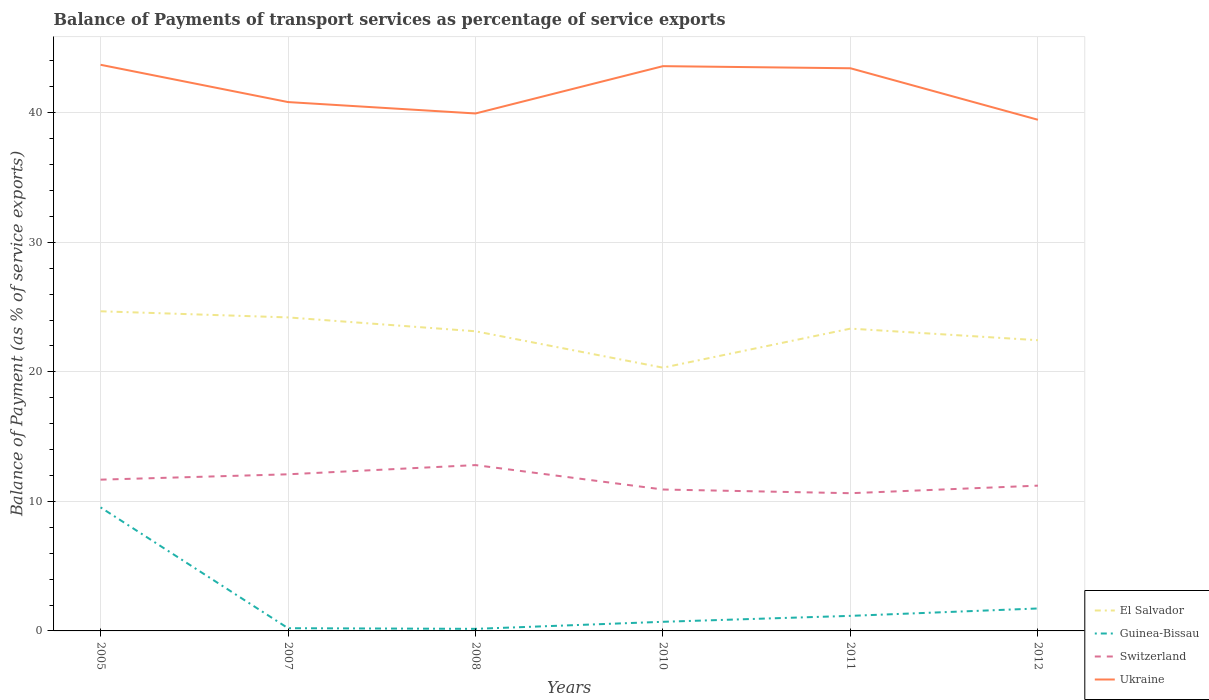How many different coloured lines are there?
Make the answer very short. 4. Across all years, what is the maximum balance of payments of transport services in Guinea-Bissau?
Offer a terse response. 0.16. What is the total balance of payments of transport services in Ukraine in the graph?
Make the answer very short. 0.11. What is the difference between the highest and the second highest balance of payments of transport services in El Salvador?
Provide a short and direct response. 4.36. How many lines are there?
Keep it short and to the point. 4. What is the difference between two consecutive major ticks on the Y-axis?
Ensure brevity in your answer.  10. Are the values on the major ticks of Y-axis written in scientific E-notation?
Your answer should be compact. No. Where does the legend appear in the graph?
Your answer should be very brief. Bottom right. How many legend labels are there?
Offer a terse response. 4. What is the title of the graph?
Offer a very short reply. Balance of Payments of transport services as percentage of service exports. What is the label or title of the Y-axis?
Your answer should be compact. Balance of Payment (as % of service exports). What is the Balance of Payment (as % of service exports) of El Salvador in 2005?
Your answer should be compact. 24.68. What is the Balance of Payment (as % of service exports) of Guinea-Bissau in 2005?
Your answer should be very brief. 9.54. What is the Balance of Payment (as % of service exports) of Switzerland in 2005?
Give a very brief answer. 11.68. What is the Balance of Payment (as % of service exports) of Ukraine in 2005?
Your answer should be compact. 43.71. What is the Balance of Payment (as % of service exports) in El Salvador in 2007?
Keep it short and to the point. 24.2. What is the Balance of Payment (as % of service exports) in Guinea-Bissau in 2007?
Provide a succinct answer. 0.21. What is the Balance of Payment (as % of service exports) of Switzerland in 2007?
Provide a succinct answer. 12.09. What is the Balance of Payment (as % of service exports) in Ukraine in 2007?
Provide a short and direct response. 40.83. What is the Balance of Payment (as % of service exports) of El Salvador in 2008?
Offer a terse response. 23.13. What is the Balance of Payment (as % of service exports) of Guinea-Bissau in 2008?
Give a very brief answer. 0.16. What is the Balance of Payment (as % of service exports) of Switzerland in 2008?
Provide a succinct answer. 12.8. What is the Balance of Payment (as % of service exports) of Ukraine in 2008?
Offer a very short reply. 39.95. What is the Balance of Payment (as % of service exports) of El Salvador in 2010?
Your response must be concise. 20.32. What is the Balance of Payment (as % of service exports) in Guinea-Bissau in 2010?
Provide a succinct answer. 0.7. What is the Balance of Payment (as % of service exports) in Switzerland in 2010?
Offer a terse response. 10.92. What is the Balance of Payment (as % of service exports) in Ukraine in 2010?
Provide a succinct answer. 43.6. What is the Balance of Payment (as % of service exports) of El Salvador in 2011?
Offer a very short reply. 23.34. What is the Balance of Payment (as % of service exports) in Guinea-Bissau in 2011?
Your answer should be compact. 1.16. What is the Balance of Payment (as % of service exports) in Switzerland in 2011?
Offer a terse response. 10.63. What is the Balance of Payment (as % of service exports) in Ukraine in 2011?
Offer a very short reply. 43.44. What is the Balance of Payment (as % of service exports) in El Salvador in 2012?
Your answer should be compact. 22.44. What is the Balance of Payment (as % of service exports) in Guinea-Bissau in 2012?
Ensure brevity in your answer.  1.73. What is the Balance of Payment (as % of service exports) in Switzerland in 2012?
Make the answer very short. 11.22. What is the Balance of Payment (as % of service exports) of Ukraine in 2012?
Give a very brief answer. 39.46. Across all years, what is the maximum Balance of Payment (as % of service exports) in El Salvador?
Provide a short and direct response. 24.68. Across all years, what is the maximum Balance of Payment (as % of service exports) in Guinea-Bissau?
Give a very brief answer. 9.54. Across all years, what is the maximum Balance of Payment (as % of service exports) in Switzerland?
Ensure brevity in your answer.  12.8. Across all years, what is the maximum Balance of Payment (as % of service exports) in Ukraine?
Give a very brief answer. 43.71. Across all years, what is the minimum Balance of Payment (as % of service exports) of El Salvador?
Keep it short and to the point. 20.32. Across all years, what is the minimum Balance of Payment (as % of service exports) of Guinea-Bissau?
Give a very brief answer. 0.16. Across all years, what is the minimum Balance of Payment (as % of service exports) of Switzerland?
Provide a succinct answer. 10.63. Across all years, what is the minimum Balance of Payment (as % of service exports) of Ukraine?
Offer a very short reply. 39.46. What is the total Balance of Payment (as % of service exports) of El Salvador in the graph?
Provide a short and direct response. 138.12. What is the total Balance of Payment (as % of service exports) of Guinea-Bissau in the graph?
Give a very brief answer. 13.51. What is the total Balance of Payment (as % of service exports) of Switzerland in the graph?
Ensure brevity in your answer.  69.34. What is the total Balance of Payment (as % of service exports) of Ukraine in the graph?
Offer a very short reply. 250.99. What is the difference between the Balance of Payment (as % of service exports) in El Salvador in 2005 and that in 2007?
Offer a terse response. 0.47. What is the difference between the Balance of Payment (as % of service exports) in Guinea-Bissau in 2005 and that in 2007?
Offer a very short reply. 9.33. What is the difference between the Balance of Payment (as % of service exports) of Switzerland in 2005 and that in 2007?
Provide a succinct answer. -0.41. What is the difference between the Balance of Payment (as % of service exports) in Ukraine in 2005 and that in 2007?
Keep it short and to the point. 2.88. What is the difference between the Balance of Payment (as % of service exports) of El Salvador in 2005 and that in 2008?
Your response must be concise. 1.54. What is the difference between the Balance of Payment (as % of service exports) of Guinea-Bissau in 2005 and that in 2008?
Make the answer very short. 9.38. What is the difference between the Balance of Payment (as % of service exports) of Switzerland in 2005 and that in 2008?
Offer a terse response. -1.12. What is the difference between the Balance of Payment (as % of service exports) in Ukraine in 2005 and that in 2008?
Your answer should be very brief. 3.76. What is the difference between the Balance of Payment (as % of service exports) of El Salvador in 2005 and that in 2010?
Your answer should be very brief. 4.36. What is the difference between the Balance of Payment (as % of service exports) in Guinea-Bissau in 2005 and that in 2010?
Make the answer very short. 8.83. What is the difference between the Balance of Payment (as % of service exports) in Switzerland in 2005 and that in 2010?
Provide a succinct answer. 0.76. What is the difference between the Balance of Payment (as % of service exports) in Ukraine in 2005 and that in 2010?
Offer a terse response. 0.11. What is the difference between the Balance of Payment (as % of service exports) of El Salvador in 2005 and that in 2011?
Offer a very short reply. 1.34. What is the difference between the Balance of Payment (as % of service exports) of Guinea-Bissau in 2005 and that in 2011?
Provide a short and direct response. 8.37. What is the difference between the Balance of Payment (as % of service exports) in Switzerland in 2005 and that in 2011?
Provide a short and direct response. 1.05. What is the difference between the Balance of Payment (as % of service exports) of Ukraine in 2005 and that in 2011?
Your answer should be compact. 0.27. What is the difference between the Balance of Payment (as % of service exports) of El Salvador in 2005 and that in 2012?
Your response must be concise. 2.23. What is the difference between the Balance of Payment (as % of service exports) of Guinea-Bissau in 2005 and that in 2012?
Make the answer very short. 7.8. What is the difference between the Balance of Payment (as % of service exports) in Switzerland in 2005 and that in 2012?
Make the answer very short. 0.46. What is the difference between the Balance of Payment (as % of service exports) in Ukraine in 2005 and that in 2012?
Keep it short and to the point. 4.25. What is the difference between the Balance of Payment (as % of service exports) in El Salvador in 2007 and that in 2008?
Keep it short and to the point. 1.07. What is the difference between the Balance of Payment (as % of service exports) of Guinea-Bissau in 2007 and that in 2008?
Provide a short and direct response. 0.05. What is the difference between the Balance of Payment (as % of service exports) of Switzerland in 2007 and that in 2008?
Your response must be concise. -0.71. What is the difference between the Balance of Payment (as % of service exports) in Ukraine in 2007 and that in 2008?
Make the answer very short. 0.88. What is the difference between the Balance of Payment (as % of service exports) of El Salvador in 2007 and that in 2010?
Offer a very short reply. 3.88. What is the difference between the Balance of Payment (as % of service exports) in Guinea-Bissau in 2007 and that in 2010?
Keep it short and to the point. -0.5. What is the difference between the Balance of Payment (as % of service exports) of Switzerland in 2007 and that in 2010?
Make the answer very short. 1.17. What is the difference between the Balance of Payment (as % of service exports) in Ukraine in 2007 and that in 2010?
Give a very brief answer. -2.77. What is the difference between the Balance of Payment (as % of service exports) in El Salvador in 2007 and that in 2011?
Give a very brief answer. 0.87. What is the difference between the Balance of Payment (as % of service exports) of Guinea-Bissau in 2007 and that in 2011?
Your answer should be compact. -0.95. What is the difference between the Balance of Payment (as % of service exports) of Switzerland in 2007 and that in 2011?
Your response must be concise. 1.46. What is the difference between the Balance of Payment (as % of service exports) of Ukraine in 2007 and that in 2011?
Your response must be concise. -2.61. What is the difference between the Balance of Payment (as % of service exports) of El Salvador in 2007 and that in 2012?
Give a very brief answer. 1.76. What is the difference between the Balance of Payment (as % of service exports) of Guinea-Bissau in 2007 and that in 2012?
Provide a succinct answer. -1.52. What is the difference between the Balance of Payment (as % of service exports) of Switzerland in 2007 and that in 2012?
Your answer should be compact. 0.88. What is the difference between the Balance of Payment (as % of service exports) of Ukraine in 2007 and that in 2012?
Give a very brief answer. 1.37. What is the difference between the Balance of Payment (as % of service exports) of El Salvador in 2008 and that in 2010?
Make the answer very short. 2.81. What is the difference between the Balance of Payment (as % of service exports) in Guinea-Bissau in 2008 and that in 2010?
Provide a succinct answer. -0.54. What is the difference between the Balance of Payment (as % of service exports) of Switzerland in 2008 and that in 2010?
Your answer should be very brief. 1.89. What is the difference between the Balance of Payment (as % of service exports) in Ukraine in 2008 and that in 2010?
Keep it short and to the point. -3.65. What is the difference between the Balance of Payment (as % of service exports) of El Salvador in 2008 and that in 2011?
Make the answer very short. -0.2. What is the difference between the Balance of Payment (as % of service exports) in Guinea-Bissau in 2008 and that in 2011?
Provide a short and direct response. -1. What is the difference between the Balance of Payment (as % of service exports) in Switzerland in 2008 and that in 2011?
Offer a very short reply. 2.17. What is the difference between the Balance of Payment (as % of service exports) of Ukraine in 2008 and that in 2011?
Provide a short and direct response. -3.49. What is the difference between the Balance of Payment (as % of service exports) in El Salvador in 2008 and that in 2012?
Give a very brief answer. 0.69. What is the difference between the Balance of Payment (as % of service exports) of Guinea-Bissau in 2008 and that in 2012?
Make the answer very short. -1.57. What is the difference between the Balance of Payment (as % of service exports) of Switzerland in 2008 and that in 2012?
Provide a succinct answer. 1.59. What is the difference between the Balance of Payment (as % of service exports) in Ukraine in 2008 and that in 2012?
Provide a short and direct response. 0.49. What is the difference between the Balance of Payment (as % of service exports) of El Salvador in 2010 and that in 2011?
Your answer should be compact. -3.02. What is the difference between the Balance of Payment (as % of service exports) in Guinea-Bissau in 2010 and that in 2011?
Your response must be concise. -0.46. What is the difference between the Balance of Payment (as % of service exports) in Switzerland in 2010 and that in 2011?
Make the answer very short. 0.28. What is the difference between the Balance of Payment (as % of service exports) in Ukraine in 2010 and that in 2011?
Offer a very short reply. 0.16. What is the difference between the Balance of Payment (as % of service exports) in El Salvador in 2010 and that in 2012?
Offer a terse response. -2.12. What is the difference between the Balance of Payment (as % of service exports) of Guinea-Bissau in 2010 and that in 2012?
Provide a short and direct response. -1.03. What is the difference between the Balance of Payment (as % of service exports) of Switzerland in 2010 and that in 2012?
Provide a short and direct response. -0.3. What is the difference between the Balance of Payment (as % of service exports) in Ukraine in 2010 and that in 2012?
Your response must be concise. 4.14. What is the difference between the Balance of Payment (as % of service exports) of El Salvador in 2011 and that in 2012?
Your answer should be compact. 0.89. What is the difference between the Balance of Payment (as % of service exports) of Guinea-Bissau in 2011 and that in 2012?
Your answer should be very brief. -0.57. What is the difference between the Balance of Payment (as % of service exports) in Switzerland in 2011 and that in 2012?
Make the answer very short. -0.58. What is the difference between the Balance of Payment (as % of service exports) of Ukraine in 2011 and that in 2012?
Your answer should be very brief. 3.98. What is the difference between the Balance of Payment (as % of service exports) of El Salvador in 2005 and the Balance of Payment (as % of service exports) of Guinea-Bissau in 2007?
Your response must be concise. 24.47. What is the difference between the Balance of Payment (as % of service exports) in El Salvador in 2005 and the Balance of Payment (as % of service exports) in Switzerland in 2007?
Your response must be concise. 12.59. What is the difference between the Balance of Payment (as % of service exports) in El Salvador in 2005 and the Balance of Payment (as % of service exports) in Ukraine in 2007?
Make the answer very short. -16.15. What is the difference between the Balance of Payment (as % of service exports) in Guinea-Bissau in 2005 and the Balance of Payment (as % of service exports) in Switzerland in 2007?
Offer a very short reply. -2.55. What is the difference between the Balance of Payment (as % of service exports) of Guinea-Bissau in 2005 and the Balance of Payment (as % of service exports) of Ukraine in 2007?
Your answer should be very brief. -31.29. What is the difference between the Balance of Payment (as % of service exports) in Switzerland in 2005 and the Balance of Payment (as % of service exports) in Ukraine in 2007?
Ensure brevity in your answer.  -29.15. What is the difference between the Balance of Payment (as % of service exports) of El Salvador in 2005 and the Balance of Payment (as % of service exports) of Guinea-Bissau in 2008?
Keep it short and to the point. 24.52. What is the difference between the Balance of Payment (as % of service exports) of El Salvador in 2005 and the Balance of Payment (as % of service exports) of Switzerland in 2008?
Your answer should be compact. 11.87. What is the difference between the Balance of Payment (as % of service exports) in El Salvador in 2005 and the Balance of Payment (as % of service exports) in Ukraine in 2008?
Give a very brief answer. -15.27. What is the difference between the Balance of Payment (as % of service exports) in Guinea-Bissau in 2005 and the Balance of Payment (as % of service exports) in Switzerland in 2008?
Offer a very short reply. -3.27. What is the difference between the Balance of Payment (as % of service exports) of Guinea-Bissau in 2005 and the Balance of Payment (as % of service exports) of Ukraine in 2008?
Ensure brevity in your answer.  -30.41. What is the difference between the Balance of Payment (as % of service exports) of Switzerland in 2005 and the Balance of Payment (as % of service exports) of Ukraine in 2008?
Make the answer very short. -28.27. What is the difference between the Balance of Payment (as % of service exports) in El Salvador in 2005 and the Balance of Payment (as % of service exports) in Guinea-Bissau in 2010?
Offer a very short reply. 23.97. What is the difference between the Balance of Payment (as % of service exports) of El Salvador in 2005 and the Balance of Payment (as % of service exports) of Switzerland in 2010?
Provide a succinct answer. 13.76. What is the difference between the Balance of Payment (as % of service exports) in El Salvador in 2005 and the Balance of Payment (as % of service exports) in Ukraine in 2010?
Your answer should be very brief. -18.92. What is the difference between the Balance of Payment (as % of service exports) in Guinea-Bissau in 2005 and the Balance of Payment (as % of service exports) in Switzerland in 2010?
Offer a terse response. -1.38. What is the difference between the Balance of Payment (as % of service exports) of Guinea-Bissau in 2005 and the Balance of Payment (as % of service exports) of Ukraine in 2010?
Your response must be concise. -34.06. What is the difference between the Balance of Payment (as % of service exports) of Switzerland in 2005 and the Balance of Payment (as % of service exports) of Ukraine in 2010?
Your response must be concise. -31.92. What is the difference between the Balance of Payment (as % of service exports) in El Salvador in 2005 and the Balance of Payment (as % of service exports) in Guinea-Bissau in 2011?
Offer a terse response. 23.51. What is the difference between the Balance of Payment (as % of service exports) of El Salvador in 2005 and the Balance of Payment (as % of service exports) of Switzerland in 2011?
Your answer should be very brief. 14.05. What is the difference between the Balance of Payment (as % of service exports) of El Salvador in 2005 and the Balance of Payment (as % of service exports) of Ukraine in 2011?
Ensure brevity in your answer.  -18.76. What is the difference between the Balance of Payment (as % of service exports) in Guinea-Bissau in 2005 and the Balance of Payment (as % of service exports) in Switzerland in 2011?
Ensure brevity in your answer.  -1.09. What is the difference between the Balance of Payment (as % of service exports) of Guinea-Bissau in 2005 and the Balance of Payment (as % of service exports) of Ukraine in 2011?
Keep it short and to the point. -33.9. What is the difference between the Balance of Payment (as % of service exports) in Switzerland in 2005 and the Balance of Payment (as % of service exports) in Ukraine in 2011?
Make the answer very short. -31.76. What is the difference between the Balance of Payment (as % of service exports) of El Salvador in 2005 and the Balance of Payment (as % of service exports) of Guinea-Bissau in 2012?
Keep it short and to the point. 22.94. What is the difference between the Balance of Payment (as % of service exports) in El Salvador in 2005 and the Balance of Payment (as % of service exports) in Switzerland in 2012?
Offer a terse response. 13.46. What is the difference between the Balance of Payment (as % of service exports) of El Salvador in 2005 and the Balance of Payment (as % of service exports) of Ukraine in 2012?
Provide a succinct answer. -14.79. What is the difference between the Balance of Payment (as % of service exports) of Guinea-Bissau in 2005 and the Balance of Payment (as % of service exports) of Switzerland in 2012?
Provide a short and direct response. -1.68. What is the difference between the Balance of Payment (as % of service exports) of Guinea-Bissau in 2005 and the Balance of Payment (as % of service exports) of Ukraine in 2012?
Give a very brief answer. -29.93. What is the difference between the Balance of Payment (as % of service exports) of Switzerland in 2005 and the Balance of Payment (as % of service exports) of Ukraine in 2012?
Ensure brevity in your answer.  -27.78. What is the difference between the Balance of Payment (as % of service exports) in El Salvador in 2007 and the Balance of Payment (as % of service exports) in Guinea-Bissau in 2008?
Keep it short and to the point. 24.04. What is the difference between the Balance of Payment (as % of service exports) in El Salvador in 2007 and the Balance of Payment (as % of service exports) in Switzerland in 2008?
Make the answer very short. 11.4. What is the difference between the Balance of Payment (as % of service exports) of El Salvador in 2007 and the Balance of Payment (as % of service exports) of Ukraine in 2008?
Your answer should be compact. -15.75. What is the difference between the Balance of Payment (as % of service exports) of Guinea-Bissau in 2007 and the Balance of Payment (as % of service exports) of Switzerland in 2008?
Offer a very short reply. -12.59. What is the difference between the Balance of Payment (as % of service exports) of Guinea-Bissau in 2007 and the Balance of Payment (as % of service exports) of Ukraine in 2008?
Your answer should be very brief. -39.74. What is the difference between the Balance of Payment (as % of service exports) of Switzerland in 2007 and the Balance of Payment (as % of service exports) of Ukraine in 2008?
Offer a very short reply. -27.86. What is the difference between the Balance of Payment (as % of service exports) in El Salvador in 2007 and the Balance of Payment (as % of service exports) in Guinea-Bissau in 2010?
Provide a short and direct response. 23.5. What is the difference between the Balance of Payment (as % of service exports) in El Salvador in 2007 and the Balance of Payment (as % of service exports) in Switzerland in 2010?
Provide a succinct answer. 13.29. What is the difference between the Balance of Payment (as % of service exports) in El Salvador in 2007 and the Balance of Payment (as % of service exports) in Ukraine in 2010?
Your response must be concise. -19.4. What is the difference between the Balance of Payment (as % of service exports) of Guinea-Bissau in 2007 and the Balance of Payment (as % of service exports) of Switzerland in 2010?
Your answer should be compact. -10.71. What is the difference between the Balance of Payment (as % of service exports) of Guinea-Bissau in 2007 and the Balance of Payment (as % of service exports) of Ukraine in 2010?
Give a very brief answer. -43.39. What is the difference between the Balance of Payment (as % of service exports) of Switzerland in 2007 and the Balance of Payment (as % of service exports) of Ukraine in 2010?
Provide a short and direct response. -31.51. What is the difference between the Balance of Payment (as % of service exports) in El Salvador in 2007 and the Balance of Payment (as % of service exports) in Guinea-Bissau in 2011?
Give a very brief answer. 23.04. What is the difference between the Balance of Payment (as % of service exports) in El Salvador in 2007 and the Balance of Payment (as % of service exports) in Switzerland in 2011?
Keep it short and to the point. 13.57. What is the difference between the Balance of Payment (as % of service exports) of El Salvador in 2007 and the Balance of Payment (as % of service exports) of Ukraine in 2011?
Your answer should be compact. -19.23. What is the difference between the Balance of Payment (as % of service exports) in Guinea-Bissau in 2007 and the Balance of Payment (as % of service exports) in Switzerland in 2011?
Provide a short and direct response. -10.42. What is the difference between the Balance of Payment (as % of service exports) in Guinea-Bissau in 2007 and the Balance of Payment (as % of service exports) in Ukraine in 2011?
Offer a terse response. -43.23. What is the difference between the Balance of Payment (as % of service exports) of Switzerland in 2007 and the Balance of Payment (as % of service exports) of Ukraine in 2011?
Provide a succinct answer. -31.35. What is the difference between the Balance of Payment (as % of service exports) of El Salvador in 2007 and the Balance of Payment (as % of service exports) of Guinea-Bissau in 2012?
Your answer should be compact. 22.47. What is the difference between the Balance of Payment (as % of service exports) of El Salvador in 2007 and the Balance of Payment (as % of service exports) of Switzerland in 2012?
Offer a very short reply. 12.99. What is the difference between the Balance of Payment (as % of service exports) in El Salvador in 2007 and the Balance of Payment (as % of service exports) in Ukraine in 2012?
Your answer should be compact. -15.26. What is the difference between the Balance of Payment (as % of service exports) of Guinea-Bissau in 2007 and the Balance of Payment (as % of service exports) of Switzerland in 2012?
Give a very brief answer. -11.01. What is the difference between the Balance of Payment (as % of service exports) of Guinea-Bissau in 2007 and the Balance of Payment (as % of service exports) of Ukraine in 2012?
Provide a short and direct response. -39.25. What is the difference between the Balance of Payment (as % of service exports) of Switzerland in 2007 and the Balance of Payment (as % of service exports) of Ukraine in 2012?
Your answer should be very brief. -27.37. What is the difference between the Balance of Payment (as % of service exports) in El Salvador in 2008 and the Balance of Payment (as % of service exports) in Guinea-Bissau in 2010?
Give a very brief answer. 22.43. What is the difference between the Balance of Payment (as % of service exports) in El Salvador in 2008 and the Balance of Payment (as % of service exports) in Switzerland in 2010?
Make the answer very short. 12.22. What is the difference between the Balance of Payment (as % of service exports) in El Salvador in 2008 and the Balance of Payment (as % of service exports) in Ukraine in 2010?
Your answer should be compact. -20.47. What is the difference between the Balance of Payment (as % of service exports) in Guinea-Bissau in 2008 and the Balance of Payment (as % of service exports) in Switzerland in 2010?
Your answer should be compact. -10.76. What is the difference between the Balance of Payment (as % of service exports) of Guinea-Bissau in 2008 and the Balance of Payment (as % of service exports) of Ukraine in 2010?
Keep it short and to the point. -43.44. What is the difference between the Balance of Payment (as % of service exports) of Switzerland in 2008 and the Balance of Payment (as % of service exports) of Ukraine in 2010?
Your response must be concise. -30.8. What is the difference between the Balance of Payment (as % of service exports) in El Salvador in 2008 and the Balance of Payment (as % of service exports) in Guinea-Bissau in 2011?
Provide a short and direct response. 21.97. What is the difference between the Balance of Payment (as % of service exports) in El Salvador in 2008 and the Balance of Payment (as % of service exports) in Switzerland in 2011?
Your response must be concise. 12.5. What is the difference between the Balance of Payment (as % of service exports) of El Salvador in 2008 and the Balance of Payment (as % of service exports) of Ukraine in 2011?
Your response must be concise. -20.3. What is the difference between the Balance of Payment (as % of service exports) in Guinea-Bissau in 2008 and the Balance of Payment (as % of service exports) in Switzerland in 2011?
Ensure brevity in your answer.  -10.47. What is the difference between the Balance of Payment (as % of service exports) in Guinea-Bissau in 2008 and the Balance of Payment (as % of service exports) in Ukraine in 2011?
Keep it short and to the point. -43.28. What is the difference between the Balance of Payment (as % of service exports) of Switzerland in 2008 and the Balance of Payment (as % of service exports) of Ukraine in 2011?
Keep it short and to the point. -30.64. What is the difference between the Balance of Payment (as % of service exports) in El Salvador in 2008 and the Balance of Payment (as % of service exports) in Guinea-Bissau in 2012?
Your answer should be very brief. 21.4. What is the difference between the Balance of Payment (as % of service exports) in El Salvador in 2008 and the Balance of Payment (as % of service exports) in Switzerland in 2012?
Give a very brief answer. 11.92. What is the difference between the Balance of Payment (as % of service exports) of El Salvador in 2008 and the Balance of Payment (as % of service exports) of Ukraine in 2012?
Give a very brief answer. -16.33. What is the difference between the Balance of Payment (as % of service exports) of Guinea-Bissau in 2008 and the Balance of Payment (as % of service exports) of Switzerland in 2012?
Offer a terse response. -11.06. What is the difference between the Balance of Payment (as % of service exports) in Guinea-Bissau in 2008 and the Balance of Payment (as % of service exports) in Ukraine in 2012?
Your answer should be compact. -39.3. What is the difference between the Balance of Payment (as % of service exports) in Switzerland in 2008 and the Balance of Payment (as % of service exports) in Ukraine in 2012?
Keep it short and to the point. -26.66. What is the difference between the Balance of Payment (as % of service exports) of El Salvador in 2010 and the Balance of Payment (as % of service exports) of Guinea-Bissau in 2011?
Your answer should be compact. 19.16. What is the difference between the Balance of Payment (as % of service exports) in El Salvador in 2010 and the Balance of Payment (as % of service exports) in Switzerland in 2011?
Your answer should be compact. 9.69. What is the difference between the Balance of Payment (as % of service exports) in El Salvador in 2010 and the Balance of Payment (as % of service exports) in Ukraine in 2011?
Provide a short and direct response. -23.12. What is the difference between the Balance of Payment (as % of service exports) of Guinea-Bissau in 2010 and the Balance of Payment (as % of service exports) of Switzerland in 2011?
Provide a succinct answer. -9.93. What is the difference between the Balance of Payment (as % of service exports) of Guinea-Bissau in 2010 and the Balance of Payment (as % of service exports) of Ukraine in 2011?
Make the answer very short. -42.73. What is the difference between the Balance of Payment (as % of service exports) of Switzerland in 2010 and the Balance of Payment (as % of service exports) of Ukraine in 2011?
Keep it short and to the point. -32.52. What is the difference between the Balance of Payment (as % of service exports) in El Salvador in 2010 and the Balance of Payment (as % of service exports) in Guinea-Bissau in 2012?
Your answer should be compact. 18.59. What is the difference between the Balance of Payment (as % of service exports) of El Salvador in 2010 and the Balance of Payment (as % of service exports) of Switzerland in 2012?
Your response must be concise. 9.11. What is the difference between the Balance of Payment (as % of service exports) in El Salvador in 2010 and the Balance of Payment (as % of service exports) in Ukraine in 2012?
Your response must be concise. -19.14. What is the difference between the Balance of Payment (as % of service exports) of Guinea-Bissau in 2010 and the Balance of Payment (as % of service exports) of Switzerland in 2012?
Your answer should be compact. -10.51. What is the difference between the Balance of Payment (as % of service exports) in Guinea-Bissau in 2010 and the Balance of Payment (as % of service exports) in Ukraine in 2012?
Provide a succinct answer. -38.76. What is the difference between the Balance of Payment (as % of service exports) in Switzerland in 2010 and the Balance of Payment (as % of service exports) in Ukraine in 2012?
Ensure brevity in your answer.  -28.55. What is the difference between the Balance of Payment (as % of service exports) of El Salvador in 2011 and the Balance of Payment (as % of service exports) of Guinea-Bissau in 2012?
Your answer should be compact. 21.6. What is the difference between the Balance of Payment (as % of service exports) of El Salvador in 2011 and the Balance of Payment (as % of service exports) of Switzerland in 2012?
Keep it short and to the point. 12.12. What is the difference between the Balance of Payment (as % of service exports) in El Salvador in 2011 and the Balance of Payment (as % of service exports) in Ukraine in 2012?
Offer a very short reply. -16.12. What is the difference between the Balance of Payment (as % of service exports) of Guinea-Bissau in 2011 and the Balance of Payment (as % of service exports) of Switzerland in 2012?
Provide a short and direct response. -10.05. What is the difference between the Balance of Payment (as % of service exports) in Guinea-Bissau in 2011 and the Balance of Payment (as % of service exports) in Ukraine in 2012?
Make the answer very short. -38.3. What is the difference between the Balance of Payment (as % of service exports) in Switzerland in 2011 and the Balance of Payment (as % of service exports) in Ukraine in 2012?
Your response must be concise. -28.83. What is the average Balance of Payment (as % of service exports) in El Salvador per year?
Your response must be concise. 23.02. What is the average Balance of Payment (as % of service exports) in Guinea-Bissau per year?
Provide a short and direct response. 2.25. What is the average Balance of Payment (as % of service exports) in Switzerland per year?
Ensure brevity in your answer.  11.56. What is the average Balance of Payment (as % of service exports) in Ukraine per year?
Offer a terse response. 41.83. In the year 2005, what is the difference between the Balance of Payment (as % of service exports) in El Salvador and Balance of Payment (as % of service exports) in Guinea-Bissau?
Ensure brevity in your answer.  15.14. In the year 2005, what is the difference between the Balance of Payment (as % of service exports) of El Salvador and Balance of Payment (as % of service exports) of Switzerland?
Make the answer very short. 13. In the year 2005, what is the difference between the Balance of Payment (as % of service exports) of El Salvador and Balance of Payment (as % of service exports) of Ukraine?
Provide a short and direct response. -19.03. In the year 2005, what is the difference between the Balance of Payment (as % of service exports) in Guinea-Bissau and Balance of Payment (as % of service exports) in Switzerland?
Make the answer very short. -2.14. In the year 2005, what is the difference between the Balance of Payment (as % of service exports) of Guinea-Bissau and Balance of Payment (as % of service exports) of Ukraine?
Ensure brevity in your answer.  -34.17. In the year 2005, what is the difference between the Balance of Payment (as % of service exports) in Switzerland and Balance of Payment (as % of service exports) in Ukraine?
Keep it short and to the point. -32.03. In the year 2007, what is the difference between the Balance of Payment (as % of service exports) in El Salvador and Balance of Payment (as % of service exports) in Guinea-Bissau?
Your answer should be compact. 23.99. In the year 2007, what is the difference between the Balance of Payment (as % of service exports) of El Salvador and Balance of Payment (as % of service exports) of Switzerland?
Ensure brevity in your answer.  12.11. In the year 2007, what is the difference between the Balance of Payment (as % of service exports) of El Salvador and Balance of Payment (as % of service exports) of Ukraine?
Make the answer very short. -16.63. In the year 2007, what is the difference between the Balance of Payment (as % of service exports) in Guinea-Bissau and Balance of Payment (as % of service exports) in Switzerland?
Make the answer very short. -11.88. In the year 2007, what is the difference between the Balance of Payment (as % of service exports) of Guinea-Bissau and Balance of Payment (as % of service exports) of Ukraine?
Keep it short and to the point. -40.62. In the year 2007, what is the difference between the Balance of Payment (as % of service exports) of Switzerland and Balance of Payment (as % of service exports) of Ukraine?
Ensure brevity in your answer.  -28.74. In the year 2008, what is the difference between the Balance of Payment (as % of service exports) in El Salvador and Balance of Payment (as % of service exports) in Guinea-Bissau?
Give a very brief answer. 22.97. In the year 2008, what is the difference between the Balance of Payment (as % of service exports) in El Salvador and Balance of Payment (as % of service exports) in Switzerland?
Offer a terse response. 10.33. In the year 2008, what is the difference between the Balance of Payment (as % of service exports) in El Salvador and Balance of Payment (as % of service exports) in Ukraine?
Ensure brevity in your answer.  -16.82. In the year 2008, what is the difference between the Balance of Payment (as % of service exports) of Guinea-Bissau and Balance of Payment (as % of service exports) of Switzerland?
Keep it short and to the point. -12.64. In the year 2008, what is the difference between the Balance of Payment (as % of service exports) in Guinea-Bissau and Balance of Payment (as % of service exports) in Ukraine?
Provide a succinct answer. -39.79. In the year 2008, what is the difference between the Balance of Payment (as % of service exports) in Switzerland and Balance of Payment (as % of service exports) in Ukraine?
Your answer should be very brief. -27.15. In the year 2010, what is the difference between the Balance of Payment (as % of service exports) in El Salvador and Balance of Payment (as % of service exports) in Guinea-Bissau?
Keep it short and to the point. 19.62. In the year 2010, what is the difference between the Balance of Payment (as % of service exports) of El Salvador and Balance of Payment (as % of service exports) of Switzerland?
Your response must be concise. 9.41. In the year 2010, what is the difference between the Balance of Payment (as % of service exports) of El Salvador and Balance of Payment (as % of service exports) of Ukraine?
Provide a short and direct response. -23.28. In the year 2010, what is the difference between the Balance of Payment (as % of service exports) in Guinea-Bissau and Balance of Payment (as % of service exports) in Switzerland?
Your answer should be compact. -10.21. In the year 2010, what is the difference between the Balance of Payment (as % of service exports) in Guinea-Bissau and Balance of Payment (as % of service exports) in Ukraine?
Provide a succinct answer. -42.9. In the year 2010, what is the difference between the Balance of Payment (as % of service exports) in Switzerland and Balance of Payment (as % of service exports) in Ukraine?
Provide a succinct answer. -32.69. In the year 2011, what is the difference between the Balance of Payment (as % of service exports) in El Salvador and Balance of Payment (as % of service exports) in Guinea-Bissau?
Your answer should be very brief. 22.18. In the year 2011, what is the difference between the Balance of Payment (as % of service exports) of El Salvador and Balance of Payment (as % of service exports) of Switzerland?
Provide a succinct answer. 12.71. In the year 2011, what is the difference between the Balance of Payment (as % of service exports) of El Salvador and Balance of Payment (as % of service exports) of Ukraine?
Provide a succinct answer. -20.1. In the year 2011, what is the difference between the Balance of Payment (as % of service exports) of Guinea-Bissau and Balance of Payment (as % of service exports) of Switzerland?
Give a very brief answer. -9.47. In the year 2011, what is the difference between the Balance of Payment (as % of service exports) of Guinea-Bissau and Balance of Payment (as % of service exports) of Ukraine?
Provide a succinct answer. -42.28. In the year 2011, what is the difference between the Balance of Payment (as % of service exports) of Switzerland and Balance of Payment (as % of service exports) of Ukraine?
Your answer should be compact. -32.81. In the year 2012, what is the difference between the Balance of Payment (as % of service exports) of El Salvador and Balance of Payment (as % of service exports) of Guinea-Bissau?
Provide a succinct answer. 20.71. In the year 2012, what is the difference between the Balance of Payment (as % of service exports) in El Salvador and Balance of Payment (as % of service exports) in Switzerland?
Provide a succinct answer. 11.23. In the year 2012, what is the difference between the Balance of Payment (as % of service exports) in El Salvador and Balance of Payment (as % of service exports) in Ukraine?
Provide a succinct answer. -17.02. In the year 2012, what is the difference between the Balance of Payment (as % of service exports) in Guinea-Bissau and Balance of Payment (as % of service exports) in Switzerland?
Offer a very short reply. -9.48. In the year 2012, what is the difference between the Balance of Payment (as % of service exports) in Guinea-Bissau and Balance of Payment (as % of service exports) in Ukraine?
Provide a short and direct response. -37.73. In the year 2012, what is the difference between the Balance of Payment (as % of service exports) in Switzerland and Balance of Payment (as % of service exports) in Ukraine?
Your answer should be compact. -28.25. What is the ratio of the Balance of Payment (as % of service exports) of El Salvador in 2005 to that in 2007?
Offer a very short reply. 1.02. What is the ratio of the Balance of Payment (as % of service exports) of Guinea-Bissau in 2005 to that in 2007?
Offer a terse response. 45.5. What is the ratio of the Balance of Payment (as % of service exports) of Switzerland in 2005 to that in 2007?
Your answer should be very brief. 0.97. What is the ratio of the Balance of Payment (as % of service exports) of Ukraine in 2005 to that in 2007?
Offer a terse response. 1.07. What is the ratio of the Balance of Payment (as % of service exports) in El Salvador in 2005 to that in 2008?
Ensure brevity in your answer.  1.07. What is the ratio of the Balance of Payment (as % of service exports) in Guinea-Bissau in 2005 to that in 2008?
Provide a short and direct response. 59.64. What is the ratio of the Balance of Payment (as % of service exports) of Switzerland in 2005 to that in 2008?
Ensure brevity in your answer.  0.91. What is the ratio of the Balance of Payment (as % of service exports) in Ukraine in 2005 to that in 2008?
Make the answer very short. 1.09. What is the ratio of the Balance of Payment (as % of service exports) in El Salvador in 2005 to that in 2010?
Ensure brevity in your answer.  1.21. What is the ratio of the Balance of Payment (as % of service exports) of Guinea-Bissau in 2005 to that in 2010?
Keep it short and to the point. 13.53. What is the ratio of the Balance of Payment (as % of service exports) of Switzerland in 2005 to that in 2010?
Give a very brief answer. 1.07. What is the ratio of the Balance of Payment (as % of service exports) of Ukraine in 2005 to that in 2010?
Give a very brief answer. 1. What is the ratio of the Balance of Payment (as % of service exports) in El Salvador in 2005 to that in 2011?
Provide a succinct answer. 1.06. What is the ratio of the Balance of Payment (as % of service exports) of Guinea-Bissau in 2005 to that in 2011?
Ensure brevity in your answer.  8.2. What is the ratio of the Balance of Payment (as % of service exports) in Switzerland in 2005 to that in 2011?
Keep it short and to the point. 1.1. What is the ratio of the Balance of Payment (as % of service exports) in El Salvador in 2005 to that in 2012?
Your answer should be very brief. 1.1. What is the ratio of the Balance of Payment (as % of service exports) in Guinea-Bissau in 2005 to that in 2012?
Your answer should be compact. 5.5. What is the ratio of the Balance of Payment (as % of service exports) of Switzerland in 2005 to that in 2012?
Your response must be concise. 1.04. What is the ratio of the Balance of Payment (as % of service exports) of Ukraine in 2005 to that in 2012?
Your answer should be compact. 1.11. What is the ratio of the Balance of Payment (as % of service exports) of El Salvador in 2007 to that in 2008?
Your response must be concise. 1.05. What is the ratio of the Balance of Payment (as % of service exports) of Guinea-Bissau in 2007 to that in 2008?
Give a very brief answer. 1.31. What is the ratio of the Balance of Payment (as % of service exports) in Switzerland in 2007 to that in 2008?
Ensure brevity in your answer.  0.94. What is the ratio of the Balance of Payment (as % of service exports) in El Salvador in 2007 to that in 2010?
Ensure brevity in your answer.  1.19. What is the ratio of the Balance of Payment (as % of service exports) in Guinea-Bissau in 2007 to that in 2010?
Provide a succinct answer. 0.3. What is the ratio of the Balance of Payment (as % of service exports) of Switzerland in 2007 to that in 2010?
Ensure brevity in your answer.  1.11. What is the ratio of the Balance of Payment (as % of service exports) of Ukraine in 2007 to that in 2010?
Offer a very short reply. 0.94. What is the ratio of the Balance of Payment (as % of service exports) in El Salvador in 2007 to that in 2011?
Your answer should be very brief. 1.04. What is the ratio of the Balance of Payment (as % of service exports) of Guinea-Bissau in 2007 to that in 2011?
Make the answer very short. 0.18. What is the ratio of the Balance of Payment (as % of service exports) of Switzerland in 2007 to that in 2011?
Give a very brief answer. 1.14. What is the ratio of the Balance of Payment (as % of service exports) in Ukraine in 2007 to that in 2011?
Offer a terse response. 0.94. What is the ratio of the Balance of Payment (as % of service exports) of El Salvador in 2007 to that in 2012?
Make the answer very short. 1.08. What is the ratio of the Balance of Payment (as % of service exports) of Guinea-Bissau in 2007 to that in 2012?
Provide a succinct answer. 0.12. What is the ratio of the Balance of Payment (as % of service exports) of Switzerland in 2007 to that in 2012?
Keep it short and to the point. 1.08. What is the ratio of the Balance of Payment (as % of service exports) of Ukraine in 2007 to that in 2012?
Provide a succinct answer. 1.03. What is the ratio of the Balance of Payment (as % of service exports) in El Salvador in 2008 to that in 2010?
Keep it short and to the point. 1.14. What is the ratio of the Balance of Payment (as % of service exports) of Guinea-Bissau in 2008 to that in 2010?
Your answer should be very brief. 0.23. What is the ratio of the Balance of Payment (as % of service exports) of Switzerland in 2008 to that in 2010?
Provide a succinct answer. 1.17. What is the ratio of the Balance of Payment (as % of service exports) in Ukraine in 2008 to that in 2010?
Your response must be concise. 0.92. What is the ratio of the Balance of Payment (as % of service exports) of El Salvador in 2008 to that in 2011?
Your answer should be compact. 0.99. What is the ratio of the Balance of Payment (as % of service exports) of Guinea-Bissau in 2008 to that in 2011?
Offer a very short reply. 0.14. What is the ratio of the Balance of Payment (as % of service exports) of Switzerland in 2008 to that in 2011?
Offer a terse response. 1.2. What is the ratio of the Balance of Payment (as % of service exports) of Ukraine in 2008 to that in 2011?
Give a very brief answer. 0.92. What is the ratio of the Balance of Payment (as % of service exports) in El Salvador in 2008 to that in 2012?
Your answer should be compact. 1.03. What is the ratio of the Balance of Payment (as % of service exports) in Guinea-Bissau in 2008 to that in 2012?
Your answer should be compact. 0.09. What is the ratio of the Balance of Payment (as % of service exports) in Switzerland in 2008 to that in 2012?
Ensure brevity in your answer.  1.14. What is the ratio of the Balance of Payment (as % of service exports) in Ukraine in 2008 to that in 2012?
Ensure brevity in your answer.  1.01. What is the ratio of the Balance of Payment (as % of service exports) of El Salvador in 2010 to that in 2011?
Offer a very short reply. 0.87. What is the ratio of the Balance of Payment (as % of service exports) of Guinea-Bissau in 2010 to that in 2011?
Your response must be concise. 0.61. What is the ratio of the Balance of Payment (as % of service exports) in Switzerland in 2010 to that in 2011?
Your answer should be compact. 1.03. What is the ratio of the Balance of Payment (as % of service exports) in El Salvador in 2010 to that in 2012?
Give a very brief answer. 0.91. What is the ratio of the Balance of Payment (as % of service exports) in Guinea-Bissau in 2010 to that in 2012?
Provide a short and direct response. 0.41. What is the ratio of the Balance of Payment (as % of service exports) in Switzerland in 2010 to that in 2012?
Your answer should be very brief. 0.97. What is the ratio of the Balance of Payment (as % of service exports) in Ukraine in 2010 to that in 2012?
Your response must be concise. 1.1. What is the ratio of the Balance of Payment (as % of service exports) of El Salvador in 2011 to that in 2012?
Your response must be concise. 1.04. What is the ratio of the Balance of Payment (as % of service exports) in Guinea-Bissau in 2011 to that in 2012?
Your answer should be very brief. 0.67. What is the ratio of the Balance of Payment (as % of service exports) of Switzerland in 2011 to that in 2012?
Your response must be concise. 0.95. What is the ratio of the Balance of Payment (as % of service exports) of Ukraine in 2011 to that in 2012?
Offer a very short reply. 1.1. What is the difference between the highest and the second highest Balance of Payment (as % of service exports) in El Salvador?
Give a very brief answer. 0.47. What is the difference between the highest and the second highest Balance of Payment (as % of service exports) in Guinea-Bissau?
Give a very brief answer. 7.8. What is the difference between the highest and the second highest Balance of Payment (as % of service exports) of Switzerland?
Provide a succinct answer. 0.71. What is the difference between the highest and the second highest Balance of Payment (as % of service exports) of Ukraine?
Make the answer very short. 0.11. What is the difference between the highest and the lowest Balance of Payment (as % of service exports) of El Salvador?
Provide a succinct answer. 4.36. What is the difference between the highest and the lowest Balance of Payment (as % of service exports) of Guinea-Bissau?
Give a very brief answer. 9.38. What is the difference between the highest and the lowest Balance of Payment (as % of service exports) in Switzerland?
Offer a very short reply. 2.17. What is the difference between the highest and the lowest Balance of Payment (as % of service exports) in Ukraine?
Your response must be concise. 4.25. 